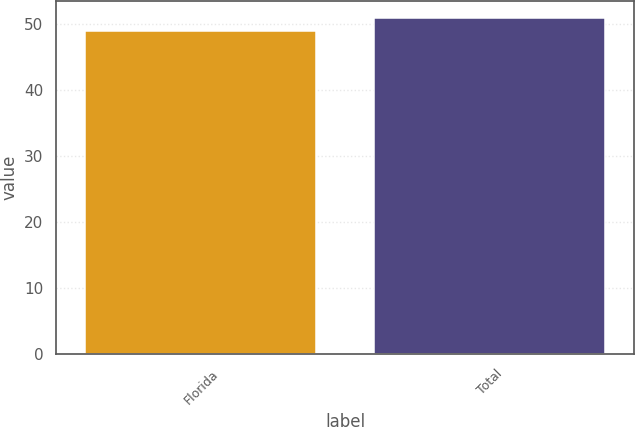Convert chart. <chart><loc_0><loc_0><loc_500><loc_500><bar_chart><fcel>Florida<fcel>Total<nl><fcel>49<fcel>51<nl></chart> 